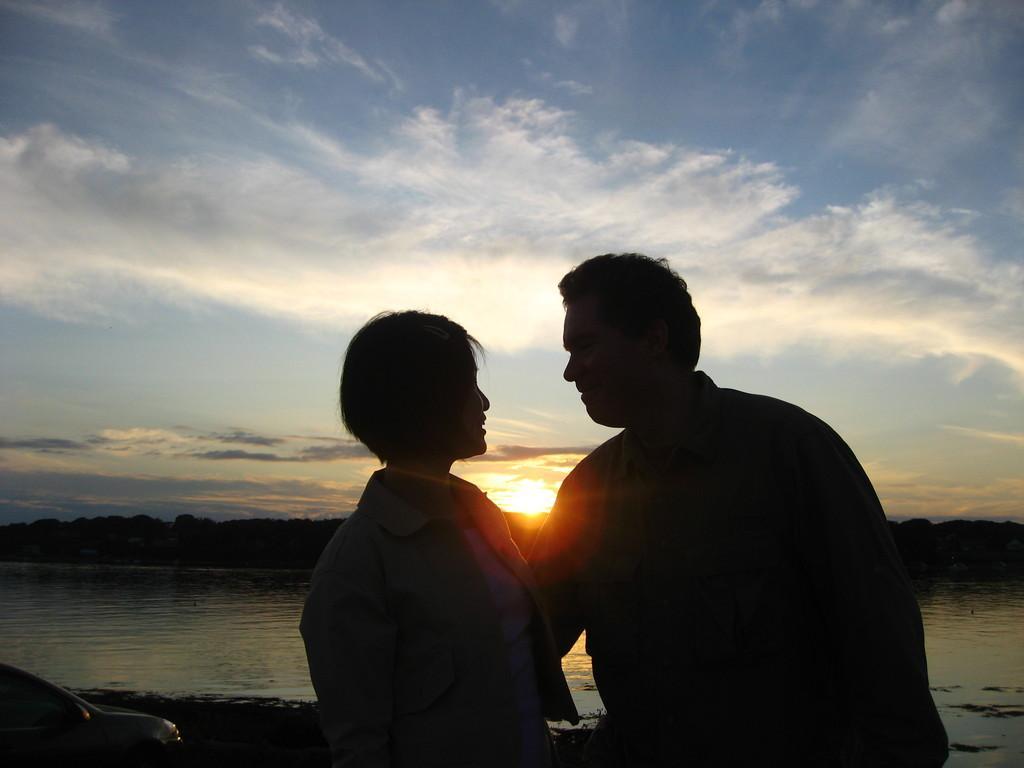Please provide a concise description of this image. In this picture we can see two people, here we can see an object and in the background we can see water, trees, sun and sky with clouds. 